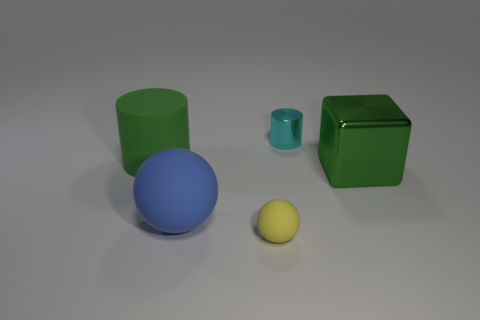Can you describe the colors and shapes of the objects shown? Certainly! There's a large green cylinder, a smaller turquoise cylinder, a blue sphere, and a smaller yellow sphere. Additionally, there's a green cube placed to the right. 